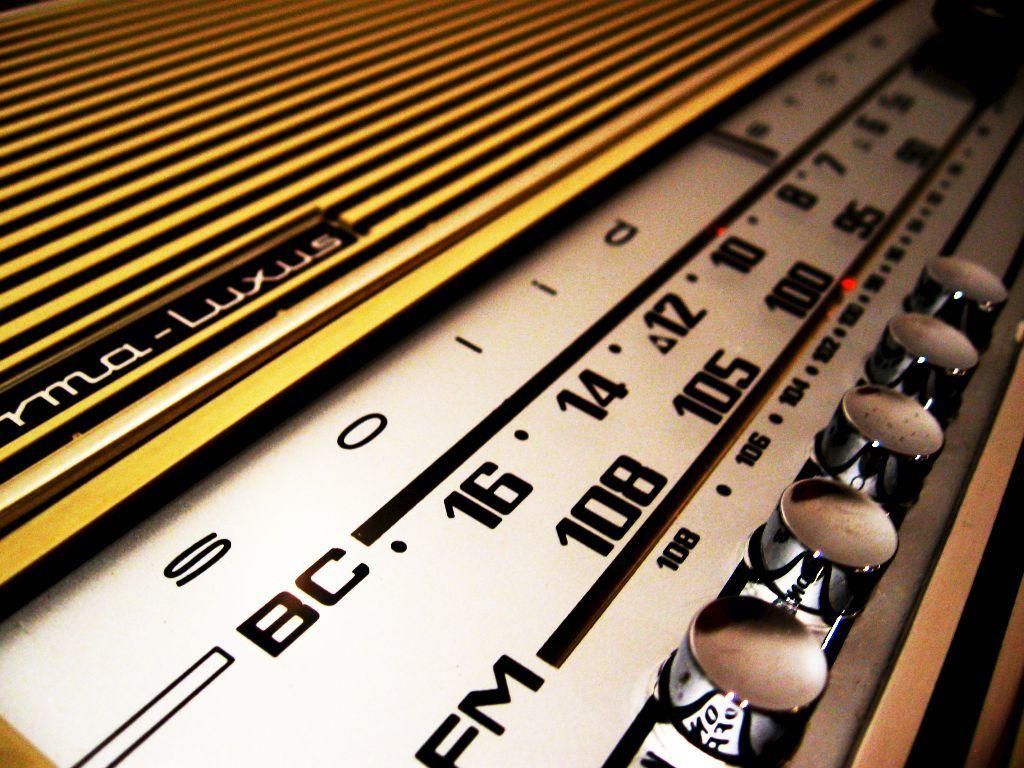What electronic device is present in the image? There is a radio in the image. What feature of the radio is mentioned in the facts? The fact states that there is text written on the radio. What type of fish can be seen swimming in the radio in the image? There is no fish present in the image, as it features a radio with text written on it. 